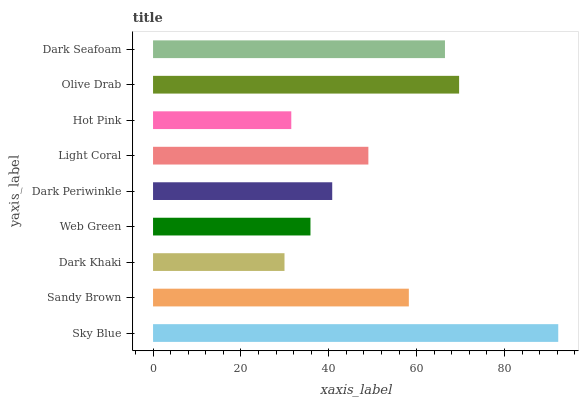Is Dark Khaki the minimum?
Answer yes or no. Yes. Is Sky Blue the maximum?
Answer yes or no. Yes. Is Sandy Brown the minimum?
Answer yes or no. No. Is Sandy Brown the maximum?
Answer yes or no. No. Is Sky Blue greater than Sandy Brown?
Answer yes or no. Yes. Is Sandy Brown less than Sky Blue?
Answer yes or no. Yes. Is Sandy Brown greater than Sky Blue?
Answer yes or no. No. Is Sky Blue less than Sandy Brown?
Answer yes or no. No. Is Light Coral the high median?
Answer yes or no. Yes. Is Light Coral the low median?
Answer yes or no. Yes. Is Sandy Brown the high median?
Answer yes or no. No. Is Dark Seafoam the low median?
Answer yes or no. No. 